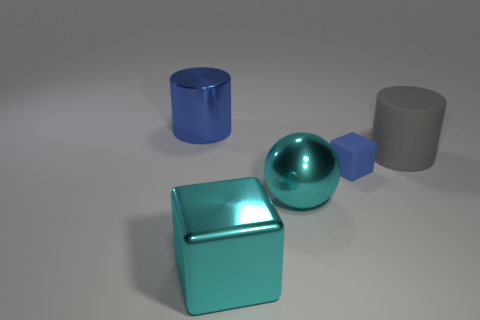There is a gray rubber cylinder that is behind the blue rubber object; what size is it?
Provide a short and direct response. Large. What number of large cubes have the same color as the small block?
Your response must be concise. 0. How many blocks are cyan metal things or blue metal things?
Your response must be concise. 1. There is a large object that is behind the big shiny ball and to the left of the blue cube; what shape is it?
Provide a short and direct response. Cylinder. Is there another yellow sphere that has the same size as the sphere?
Your answer should be compact. No. How many things are shiny objects in front of the large gray rubber cylinder or large blocks?
Ensure brevity in your answer.  2. Is the material of the blue cube the same as the big cyan thing that is behind the big cyan cube?
Provide a short and direct response. No. How many other things are there of the same shape as the small blue thing?
Offer a very short reply. 1. How many objects are either cylinders that are to the right of the blue cylinder or large metallic objects that are in front of the large gray cylinder?
Offer a terse response. 3. How many other things are the same color as the big shiny cube?
Your answer should be very brief. 1. 